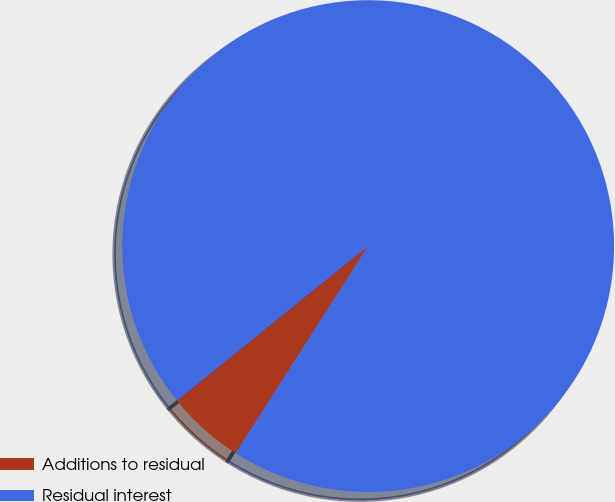<chart> <loc_0><loc_0><loc_500><loc_500><pie_chart><fcel>Additions to residual<fcel>Residual interest<nl><fcel>5.12%<fcel>94.88%<nl></chart> 